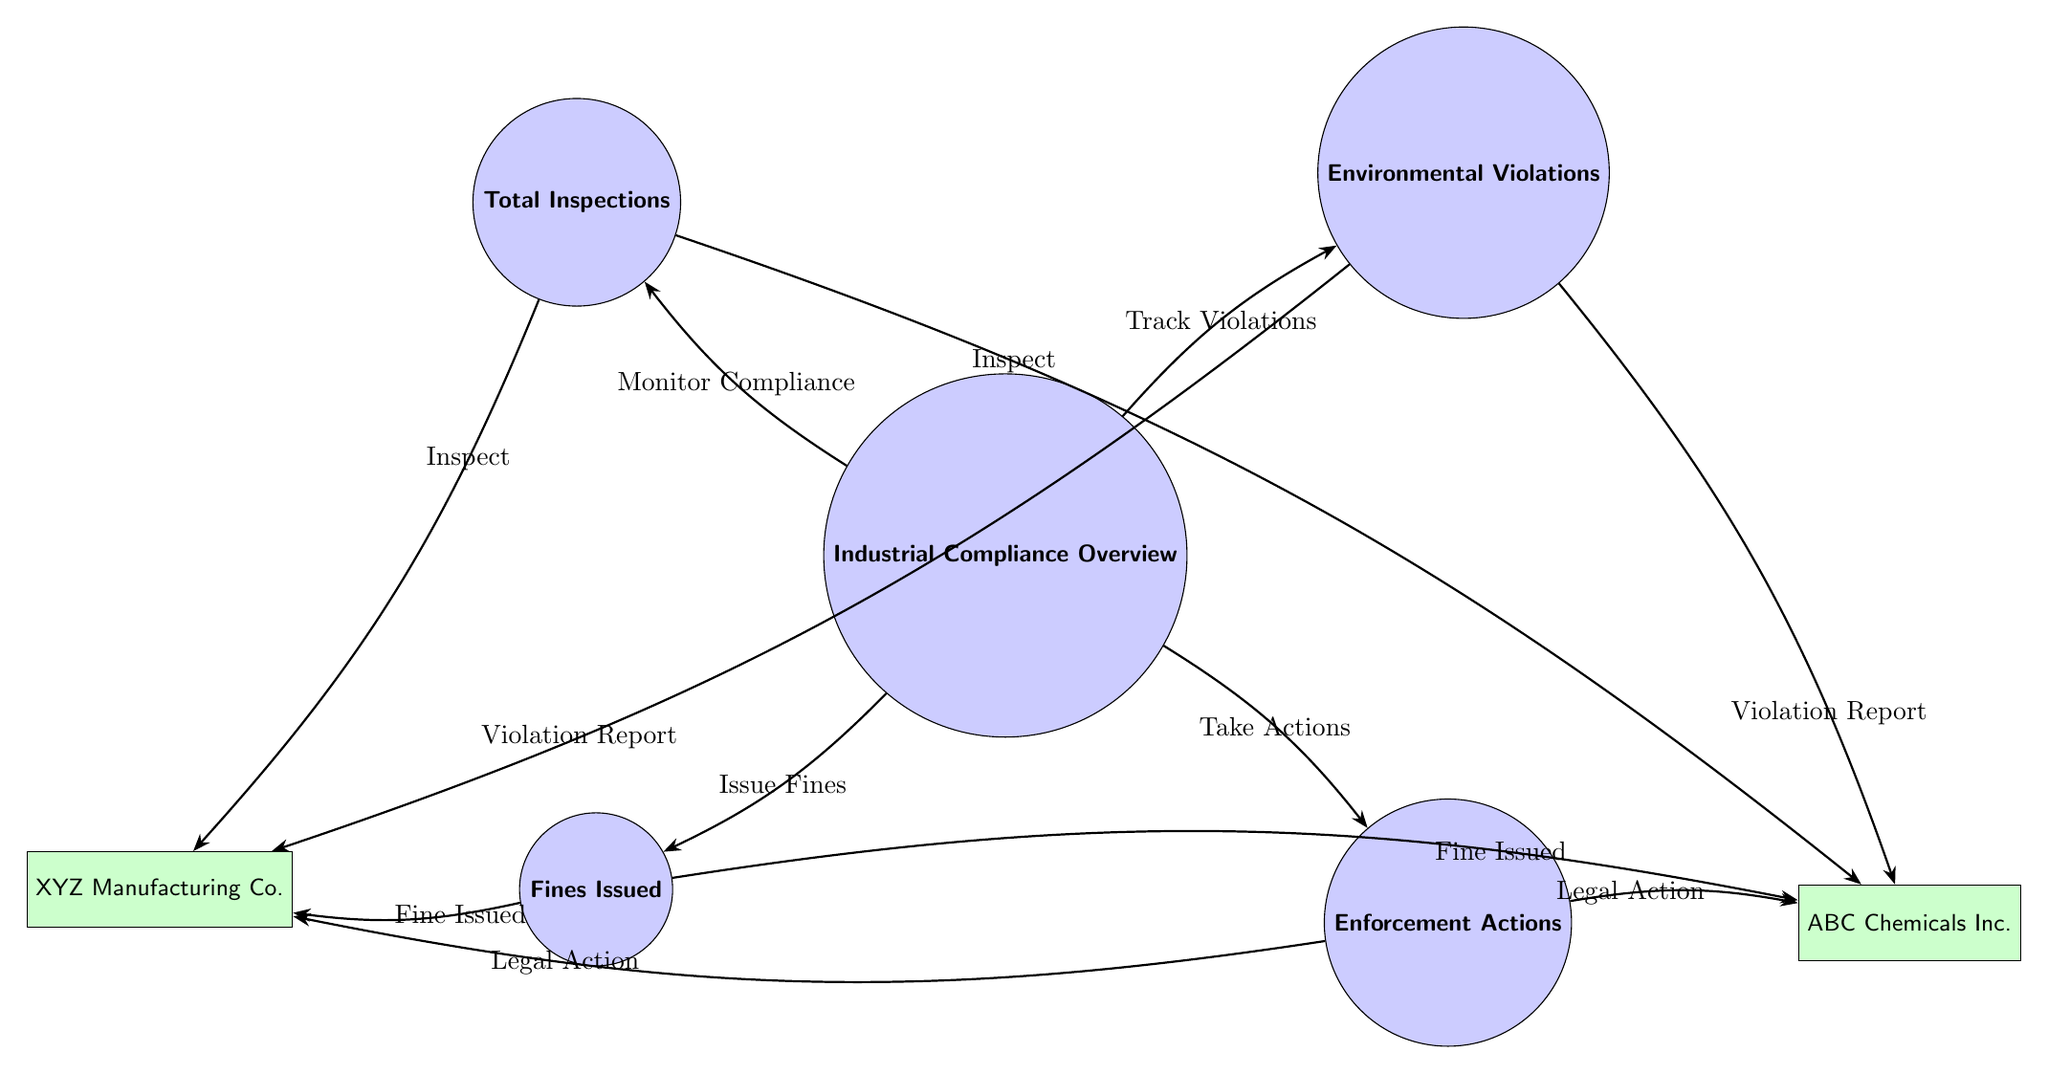What is the central theme of this diagram? The diagram centers around "Industrial Compliance Overview," as indicated by the main node. This node serves as the focal point from which various aspects of compliance are monitored and enforced.
Answer: Industrial Compliance Overview How many total nodes are present in the diagram? By counting all the circular and rectangular nodes in the diagram, we find there are six nodes in total. This includes one main node and five additional nodes for inspections, violations, fines, actions, and companies.
Answer: 6 Which companies are mentioned in the diagram? The diagram features two specific companies: "XYZ Manufacturing Co." and "ABC Chemicals Inc." Each company is represented by a rectangular node on different sides of the diagram, connecting to the various actions taken against them.
Answer: XYZ Manufacturing Co., ABC Chemicals Inc What action is taken towards both companies for environmental violations? For both companies, the action taken for environmental violations is "Legal Action," as per the edges connecting the enforcement actions to each company node in the diagram.
Answer: Legal Action What relation exists between total inspections and environmental violations? The relationship is defined as "Track Violations," which indicates that monitoring compliance through inspections leads to the identification and tracking of any environmental violations.
Answer: Track Violations How many enforcement actions are depicted in the diagram? The diagram shows a single node labeled "Enforcement Actions," indicating that this represents a collective set of actions taken rather than multiple distinct actions.
Answer: 1 Which node indicates the tracking of inspections? The node that indicates tracking inspections is labeled "Total Inspections," positioned above the central "Industrial Compliance Overview" node, showing the process of monitoring compliance starts with inspections.
Answer: Total Inspections What is the connection between the fines issued and the companies? The connection is characterized by the edge labeled "Fine Issued," which illustrates that fines are specifically issued to both companies when they are found in violation of environmental regulations.
Answer: Fine Issued 